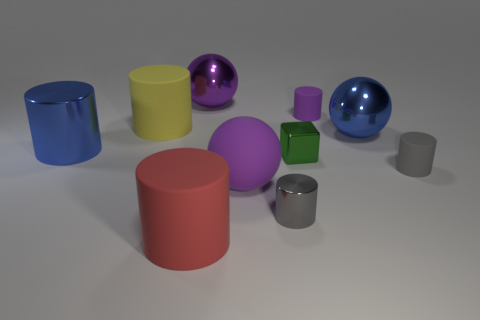Subtract all large rubber cylinders. How many cylinders are left? 4 Subtract all blue cylinders. How many cylinders are left? 5 Subtract all purple cylinders. Subtract all gray spheres. How many cylinders are left? 5 Subtract all balls. How many objects are left? 7 Add 8 tiny metal things. How many tiny metal things are left? 10 Add 5 purple shiny blocks. How many purple shiny blocks exist? 5 Subtract 2 gray cylinders. How many objects are left? 8 Subtract all small purple rubber things. Subtract all gray cylinders. How many objects are left? 7 